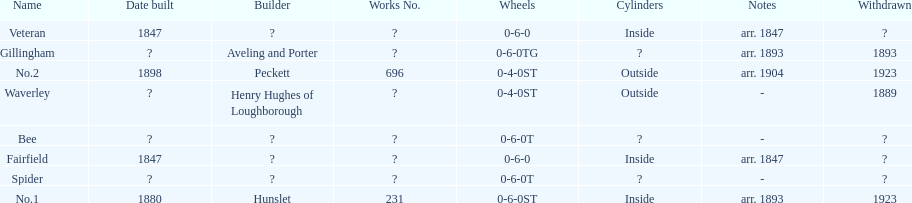Parse the full table. {'header': ['Name', 'Date built', 'Builder', 'Works No.', 'Wheels', 'Cylinders', 'Notes', 'Withdrawn'], 'rows': [['Veteran', '1847', '?', '?', '0-6-0', 'Inside', 'arr. 1847', '?'], ['Gillingham', '?', 'Aveling and Porter', '?', '0-6-0TG', '?', 'arr. 1893', '1893'], ['No.2', '1898', 'Peckett', '696', '0-4-0ST', 'Outside', 'arr. 1904', '1923'], ['Waverley', '?', 'Henry Hughes of Loughborough', '?', '0-4-0ST', 'Outside', '-', '1889'], ['Bee', '?', '?', '?', '0-6-0T', '?', '-', '?'], ['Fairfield', '1847', '?', '?', '0-6-0', 'Inside', 'arr. 1847', '?'], ['Spider', '?', '?', '?', '0-6-0T', '?', '-', '?'], ['No.1', '1880', 'Hunslet', '231', '0-6-0ST', 'Inside', 'arr. 1893', '1923']]} How long after fairfield was no. 1 built? 33 years. 